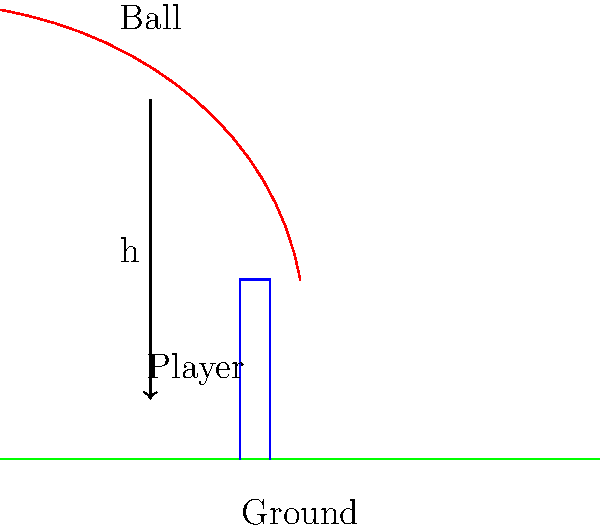In a cricket match at Lord's, a player jumps to catch a ball. The ball is at a height of 5 meters when the player begins to jump. If the player's center of mass rises by 1.2 meters during the jump and they successfully catch the ball at the highest point, what is the speed of the ball just before it's caught? Assume no air resistance and that the ball's initial velocity is purely horizontal. (Use g = 9.8 m/s²) Let's approach this step-by-step using the principle of conservation of energy:

1) First, we need to find the height at which the ball is caught. This is:
   Initial height - Player's jump height = 5 m - 1.2 m = 3.8 m

2) The ball loses potential energy as it falls. This energy is converted to kinetic energy. We can use the equation:
   $$\Delta PE = -\Delta KE$$

3) The change in potential energy is:
   $$\Delta PE = mg\Delta h = m(9.8)(3.8 - 5) = -11.76m \text{ J}$$
   Where m is the mass of the ball.

4) This means the ball gains 11.76m J of kinetic energy.

5) We can find the final velocity using the kinetic energy equation:
   $$KE = \frac{1}{2}mv^2$$
   $$11.76m = \frac{1}{2}mv^2$$

6) Simplifying:
   $$23.52 = v^2$$

7) Taking the square root of both sides:
   $$v = \sqrt{23.52} = 4.85 \text{ m/s}$$

Therefore, the speed of the ball just before it's caught is approximately 4.85 m/s.
Answer: 4.85 m/s 